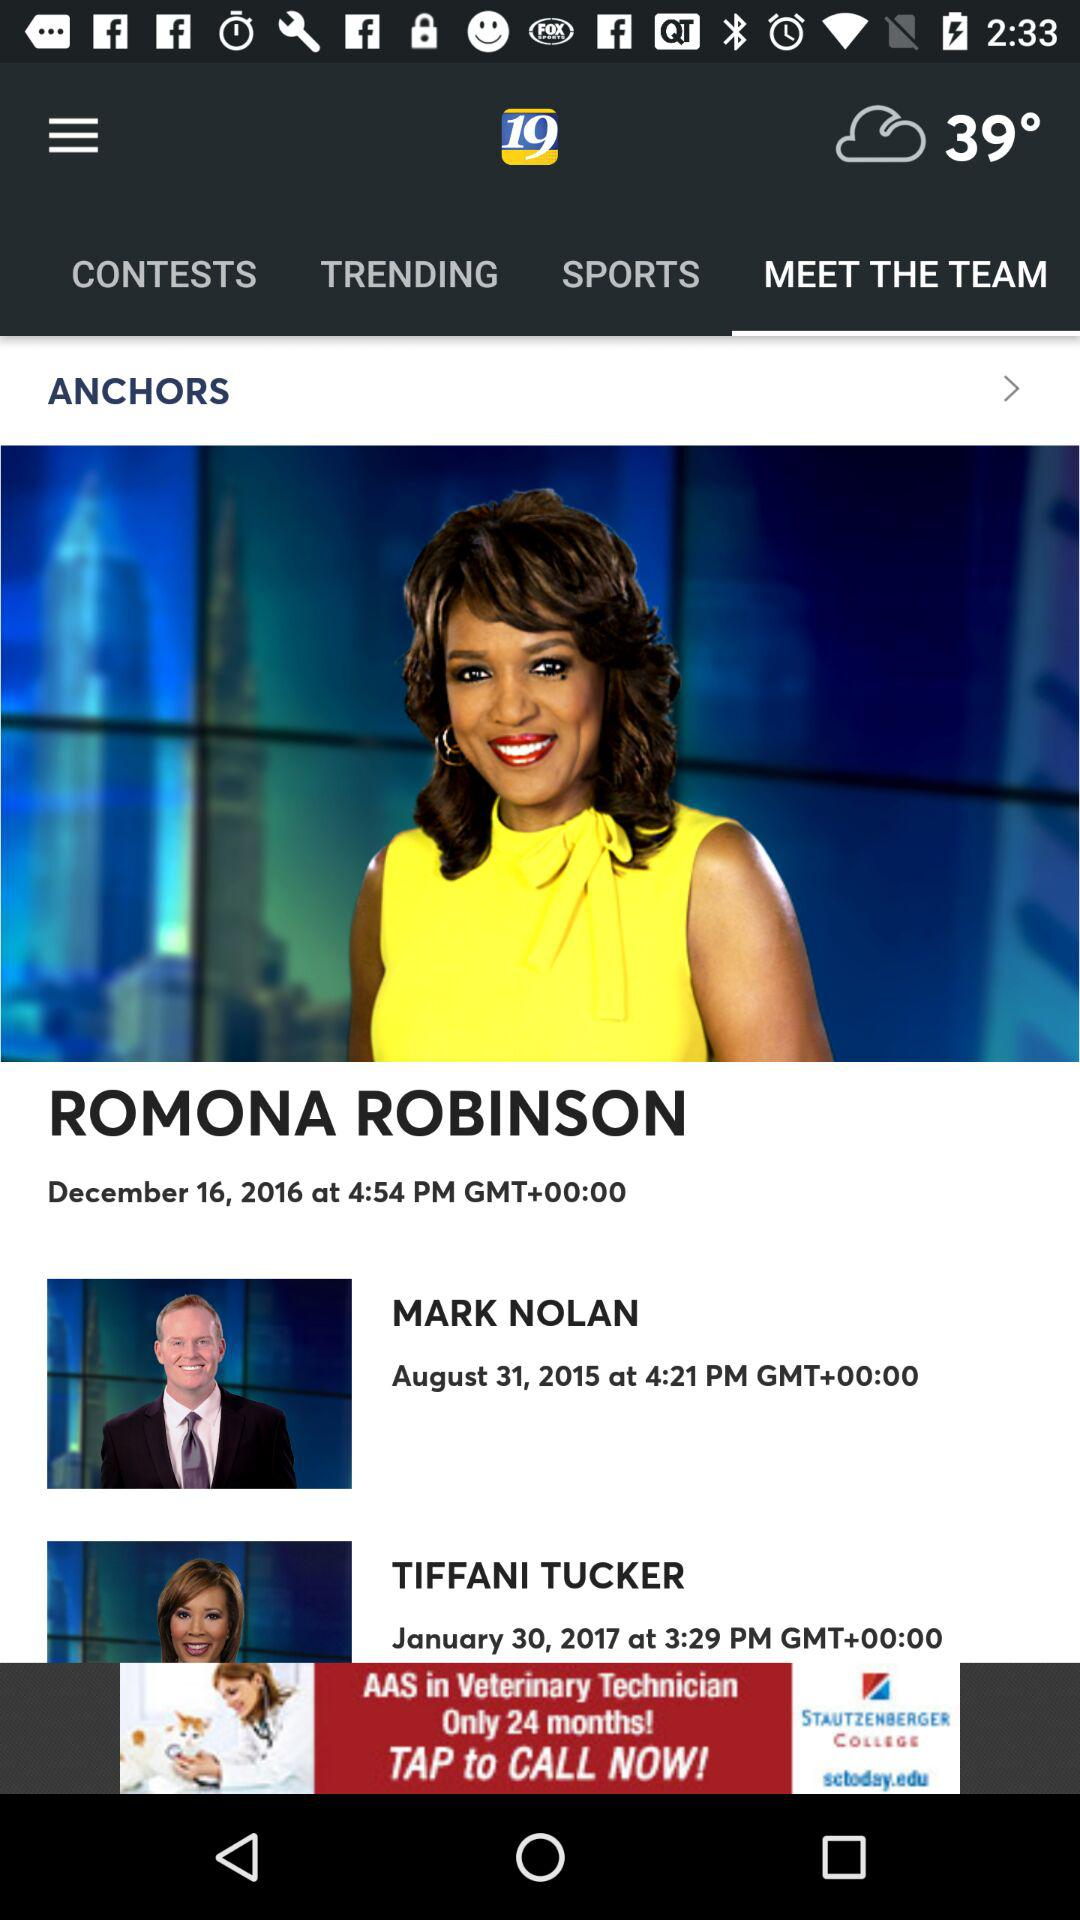What is the temperature? The temperature is 39°. 